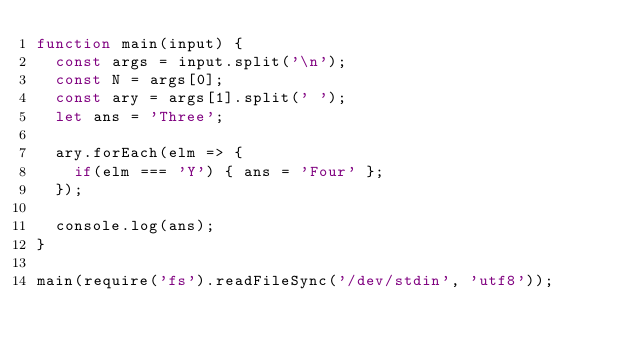Convert code to text. <code><loc_0><loc_0><loc_500><loc_500><_JavaScript_>function main(input) {
  const args = input.split('\n');
  const N = args[0];
  const ary = args[1].split(' ');
  let ans = 'Three';
  
  ary.forEach(elm => {
    if(elm === 'Y') { ans = 'Four' };
  });
  
  console.log(ans);
}

main(require('fs').readFileSync('/dev/stdin', 'utf8'));</code> 